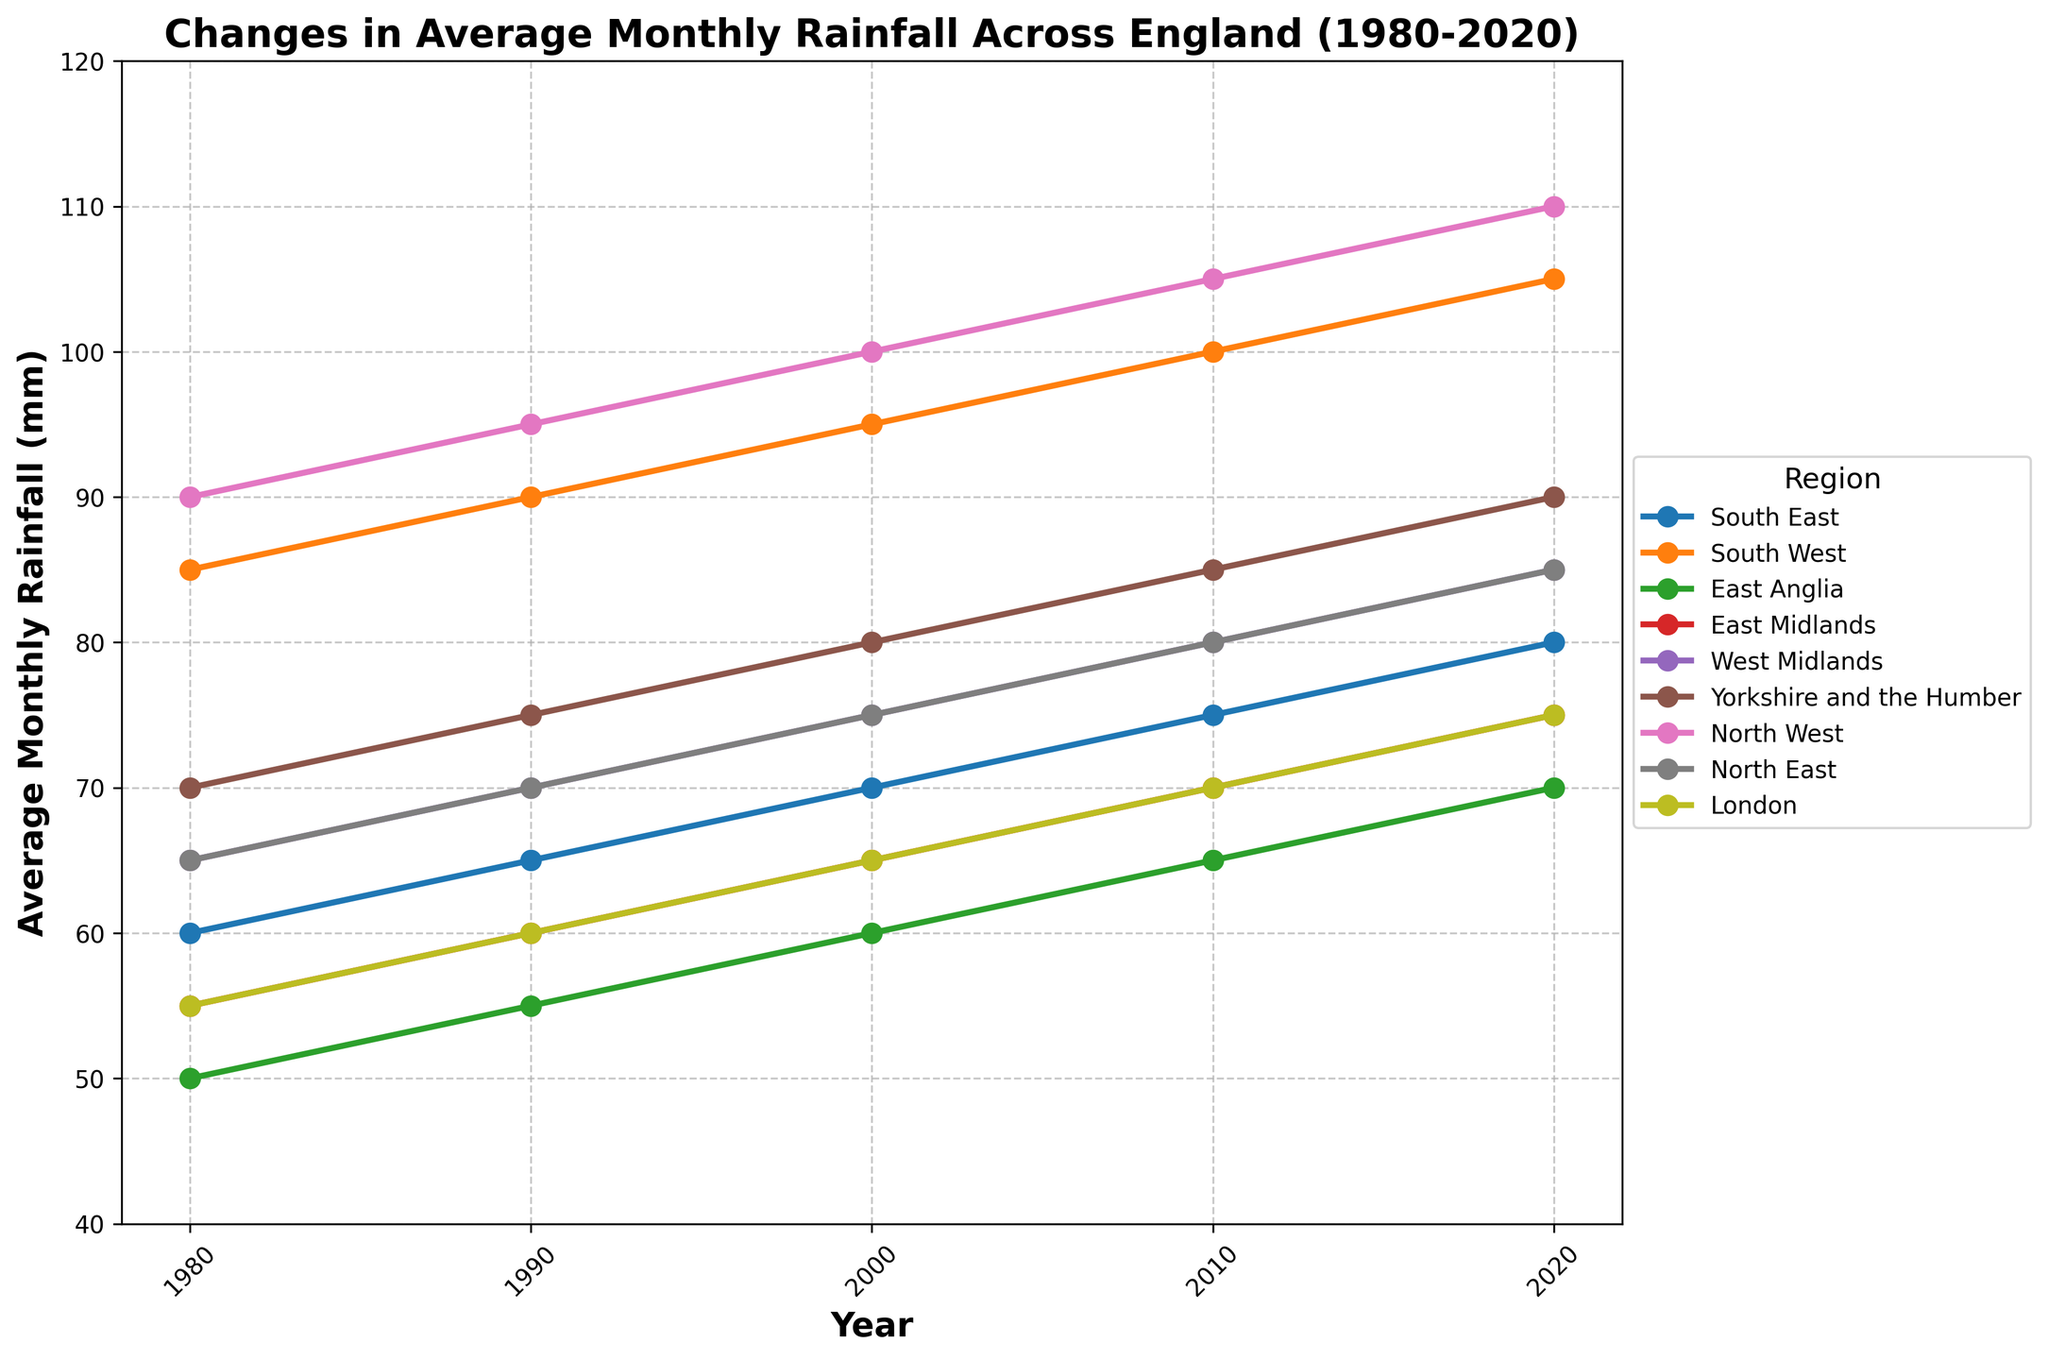What region had the highest average monthly rainfall in 1980? To identify the region with the highest rainfall in 1980, look at the data for 1980 for all regions and find the maximum value. The North West had the highest average monthly rainfall at 90 mm.
Answer: North West Which region had the lowest increase in average monthly rainfall from 1980 to 2020? Calculate the difference in rainfall from 1980 to 2020 for each region and compare them to find the smallest value. East Anglia increased from 50 mm to 70 mm, which is the lowest increase of 20 mm.
Answer: East Anglia By how much did average monthly rainfall in the South West increase from 1980 to 2020? Calculate the difference between the values in 1980 and 2020 for the South West. The value in 1980 was 85 mm, and in 2020 it was 105 mm. So, 105 - 85 = 20 mm.
Answer: 20 mm Which region had the highest consistent increase in average monthly rainfall across all periods shown? Analyze the increases for each decade for each region. The North West consistently increases by 5 mm per decade from 1980 to 2020. Other regions don't have this consistent pattern.
Answer: North West Which two regions had equal average monthly rainfall in 2010? Check the values in 2010 for all regions and identify any that are the same. Both North East and West Midlands had an average monthly rainfall of 80 mm in 2010.
Answer: North East and West Midlands In which year did London reach an average monthly rainfall of 70 mm? Trace the values for London across the years and find when it reached 70 mm. The year is 2010.
Answer: 2010 Was there any region with no increase in average monthly rainfall between 2010 and 2020? Compare the values for 2010 and 2020 for each region to see if any remained the same. All regions show an increase in rainfall between these years.
Answer: No What is the range of average monthly rainfall for East Anglia over the given years? Find the minimum and maximum values for East Anglia from the data. The minimum is 50 mm (1980), and the maximum is 70 mm (2020), giving a range of 70 - 50 = 20 mm.
Answer: 20 mm Which region had a higher average monthly rainfall in 2000, East Midlands or London? Compare the values for East Midlands and London in 2000. East Midlands had 65 mm, while London had 65 mm, so they were equal.
Answer: Equal What is the average growth in average monthly rainfall per decade for Yorkshire and the Humber from 1980 to 2020? Calculate the growth for each decade and then find the average. The years are 80 to 90 is 75-70=5, 90 to 2000 is 80-75=5, 2000 to 2010 is 85-80=5, 2010 to 2020 is 90-85=5. Average of these (5+5+5+5)/4 = 5mm per decade.
Answer: 5 mm per decade 